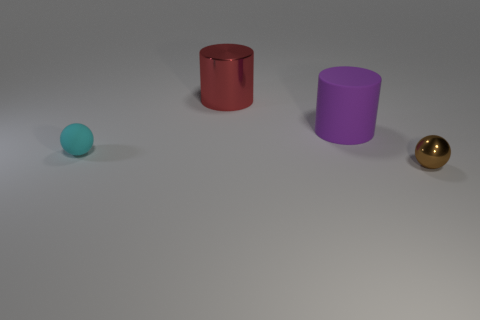Subtract all yellow spheres. Subtract all green blocks. How many spheres are left? 2 Add 2 big purple objects. How many objects exist? 6 Add 3 tiny rubber things. How many tiny rubber things exist? 4 Subtract 0 red balls. How many objects are left? 4 Subtract all red metallic cylinders. Subtract all matte things. How many objects are left? 1 Add 4 matte things. How many matte things are left? 6 